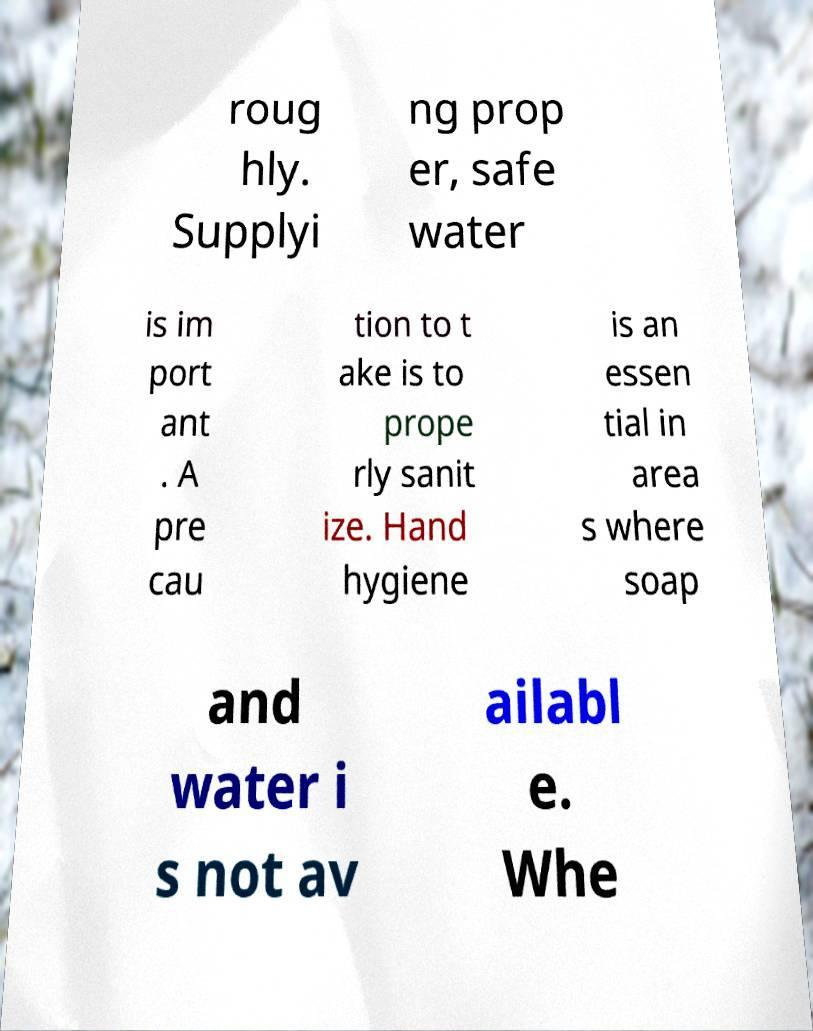Can you accurately transcribe the text from the provided image for me? roug hly. Supplyi ng prop er, safe water is im port ant . A pre cau tion to t ake is to prope rly sanit ize. Hand hygiene is an essen tial in area s where soap and water i s not av ailabl e. Whe 